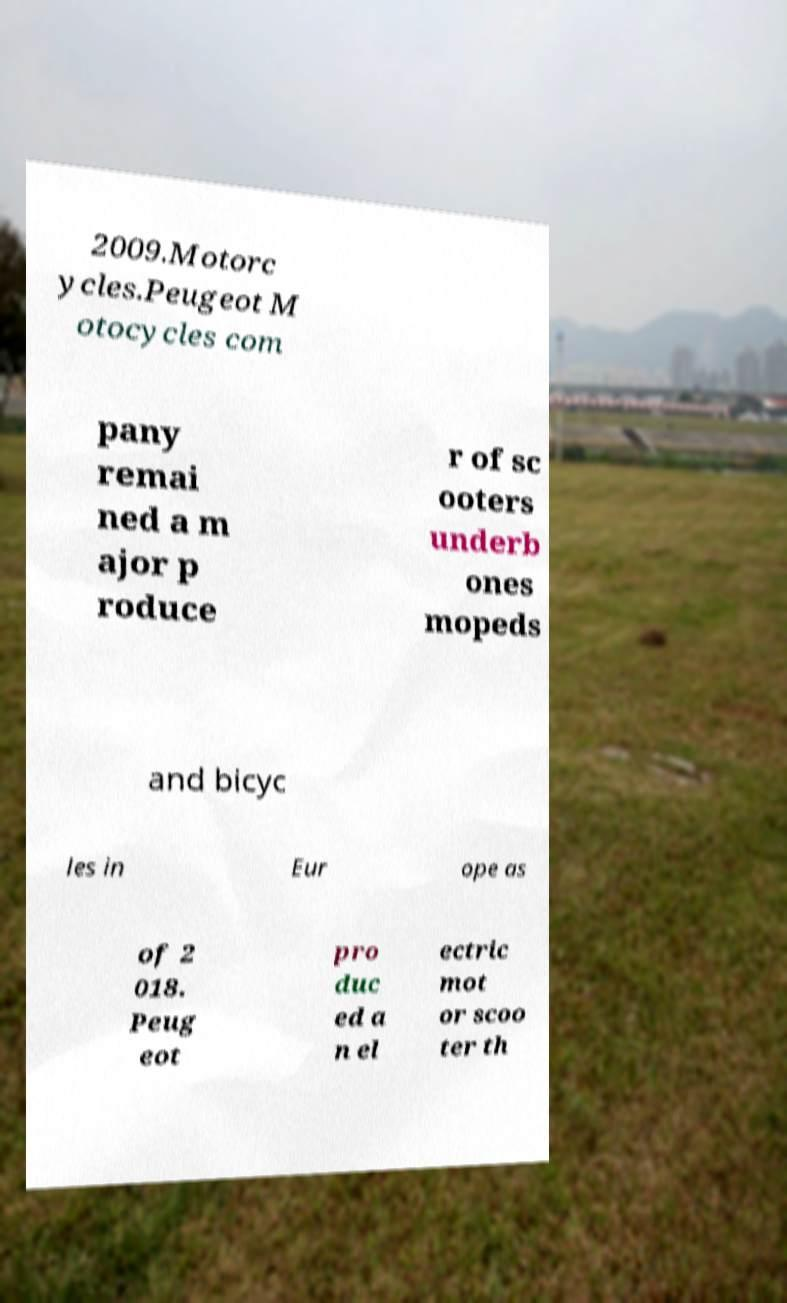Can you accurately transcribe the text from the provided image for me? 2009.Motorc ycles.Peugeot M otocycles com pany remai ned a m ajor p roduce r of sc ooters underb ones mopeds and bicyc les in Eur ope as of 2 018. Peug eot pro duc ed a n el ectric mot or scoo ter th 